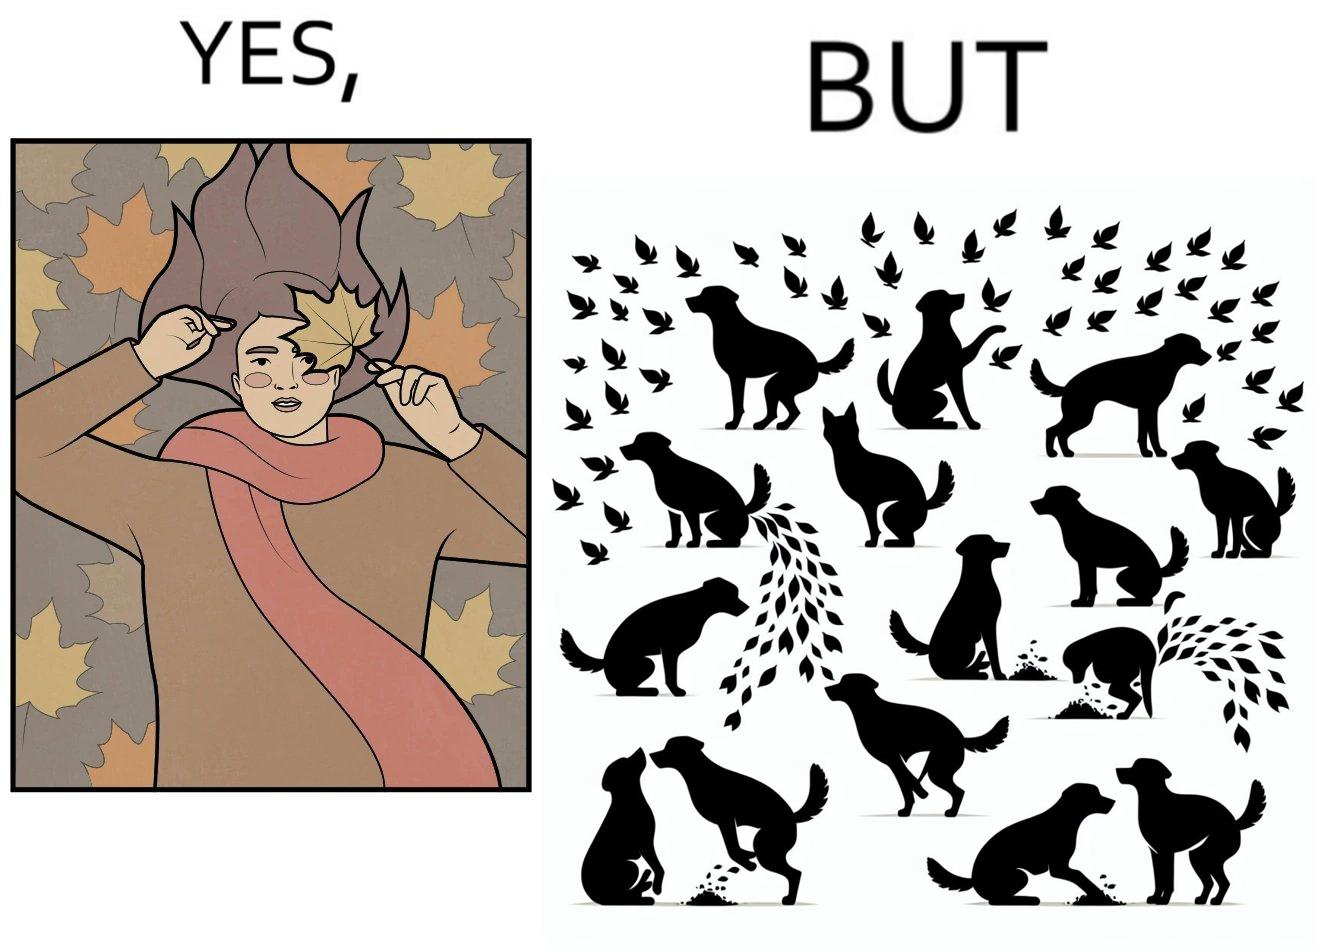Describe the content of this image. The images are funny since it show a woman holding a leaf over half of her face for a good photo but unknown to her is thale fact the same leaf might have been defecated or urinated upon by dogs and other wild animals 